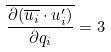Convert formula to latex. <formula><loc_0><loc_0><loc_500><loc_500>\overline { \frac { \partial ( \overline { u _ { i } } \cdot u _ { i } ^ { \prime } ) } { \partial q _ { i } } } = 3</formula> 